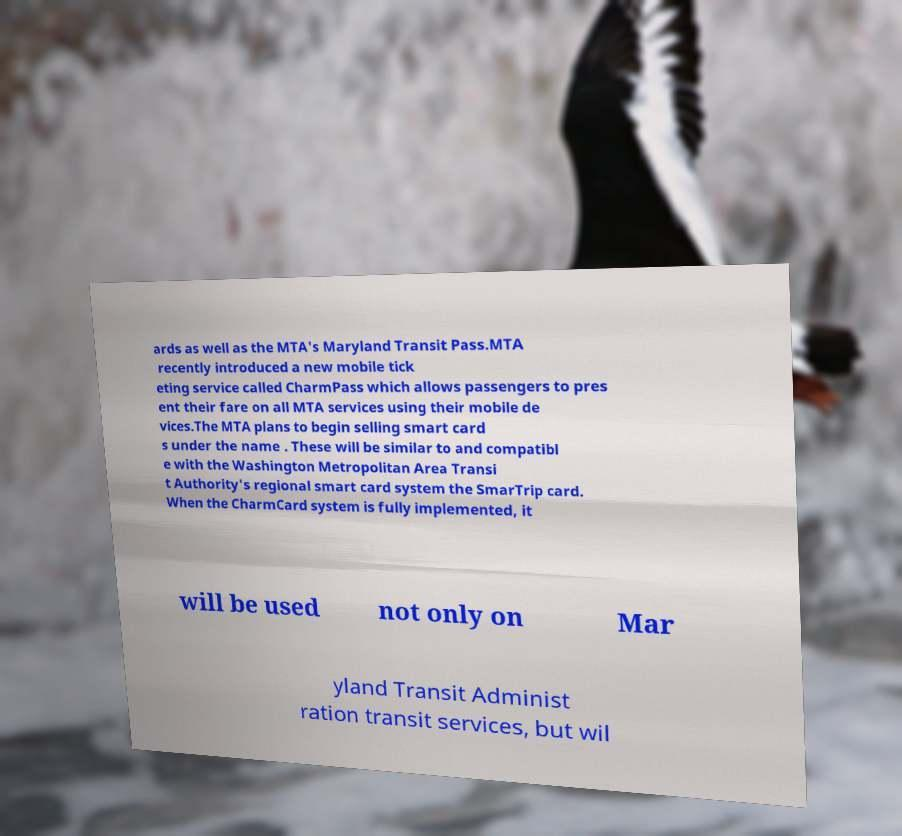There's text embedded in this image that I need extracted. Can you transcribe it verbatim? ards as well as the MTA's Maryland Transit Pass.MTA recently introduced a new mobile tick eting service called CharmPass which allows passengers to pres ent their fare on all MTA services using their mobile de vices.The MTA plans to begin selling smart card s under the name . These will be similar to and compatibl e with the Washington Metropolitan Area Transi t Authority's regional smart card system the SmarTrip card. When the CharmCard system is fully implemented, it will be used not only on Mar yland Transit Administ ration transit services, but wil 